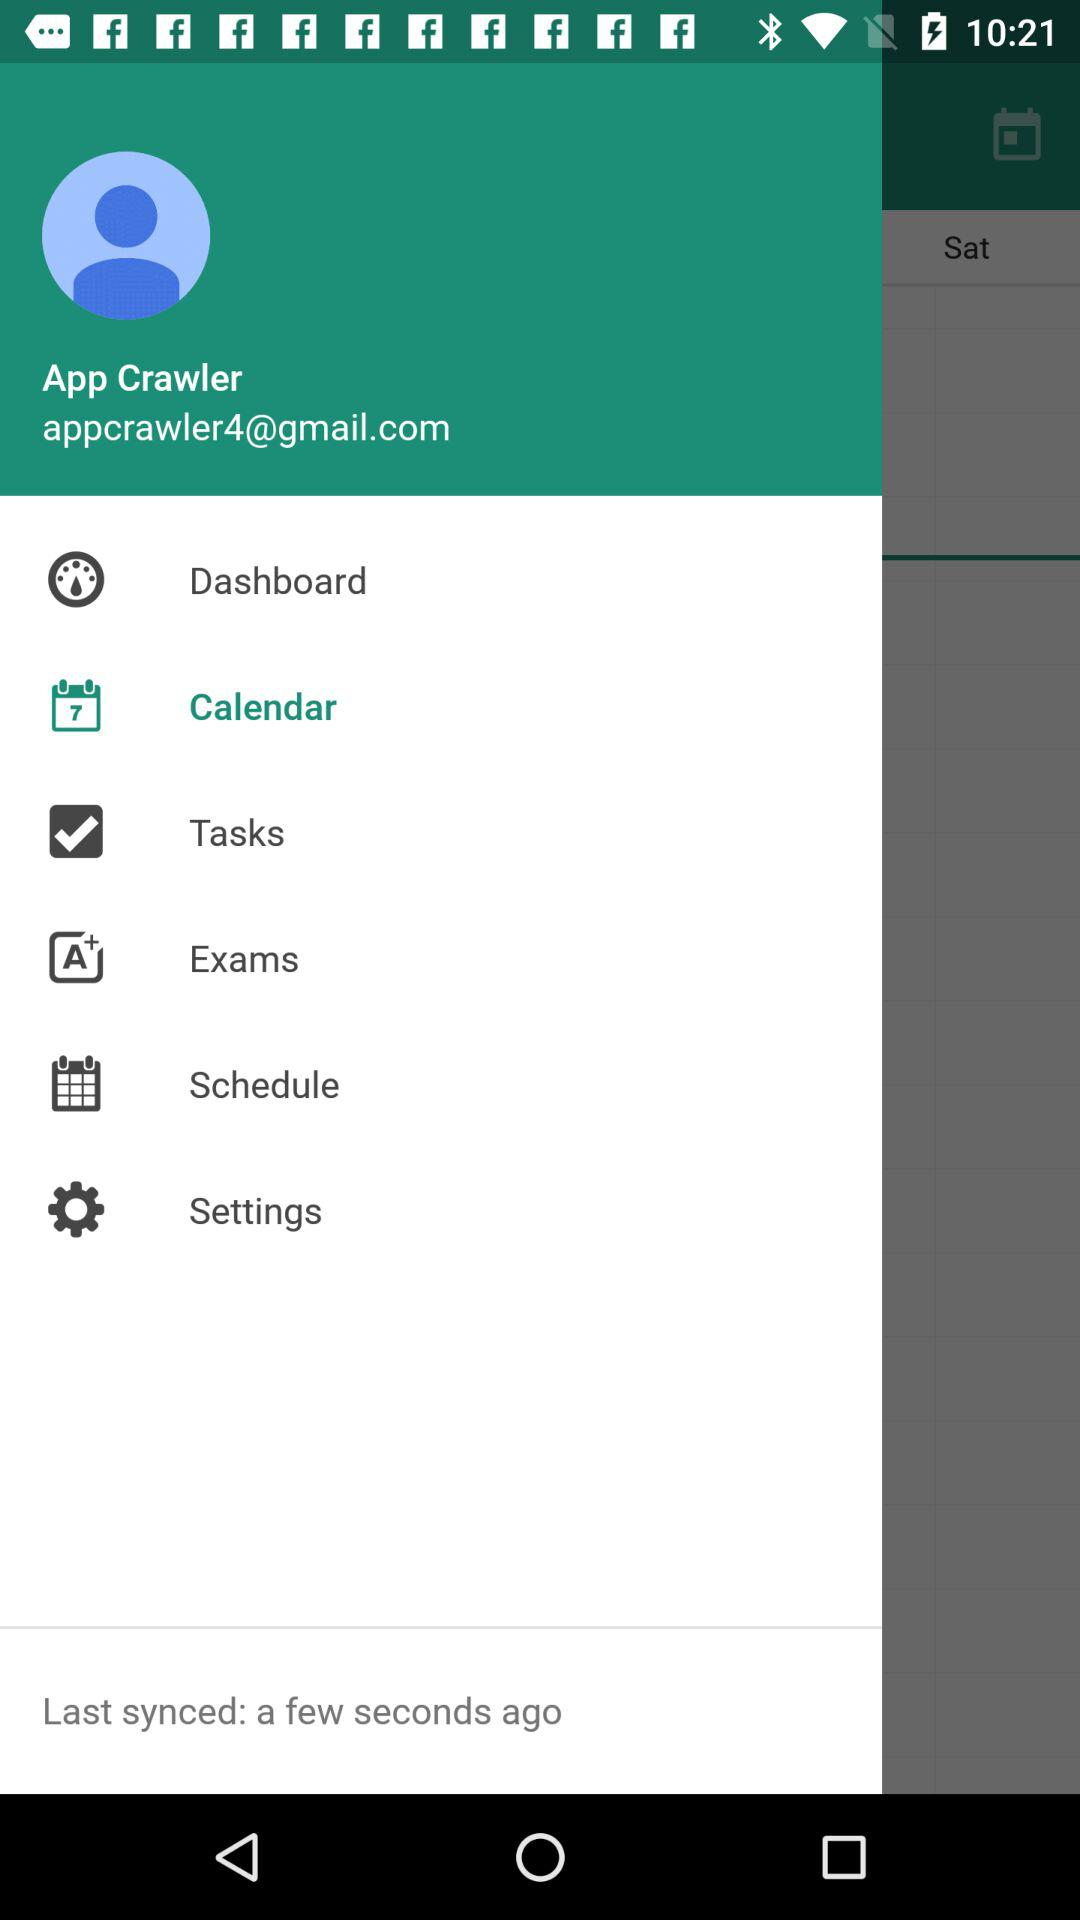What is the email address? The email address is appcrawler4@gmail.com. 